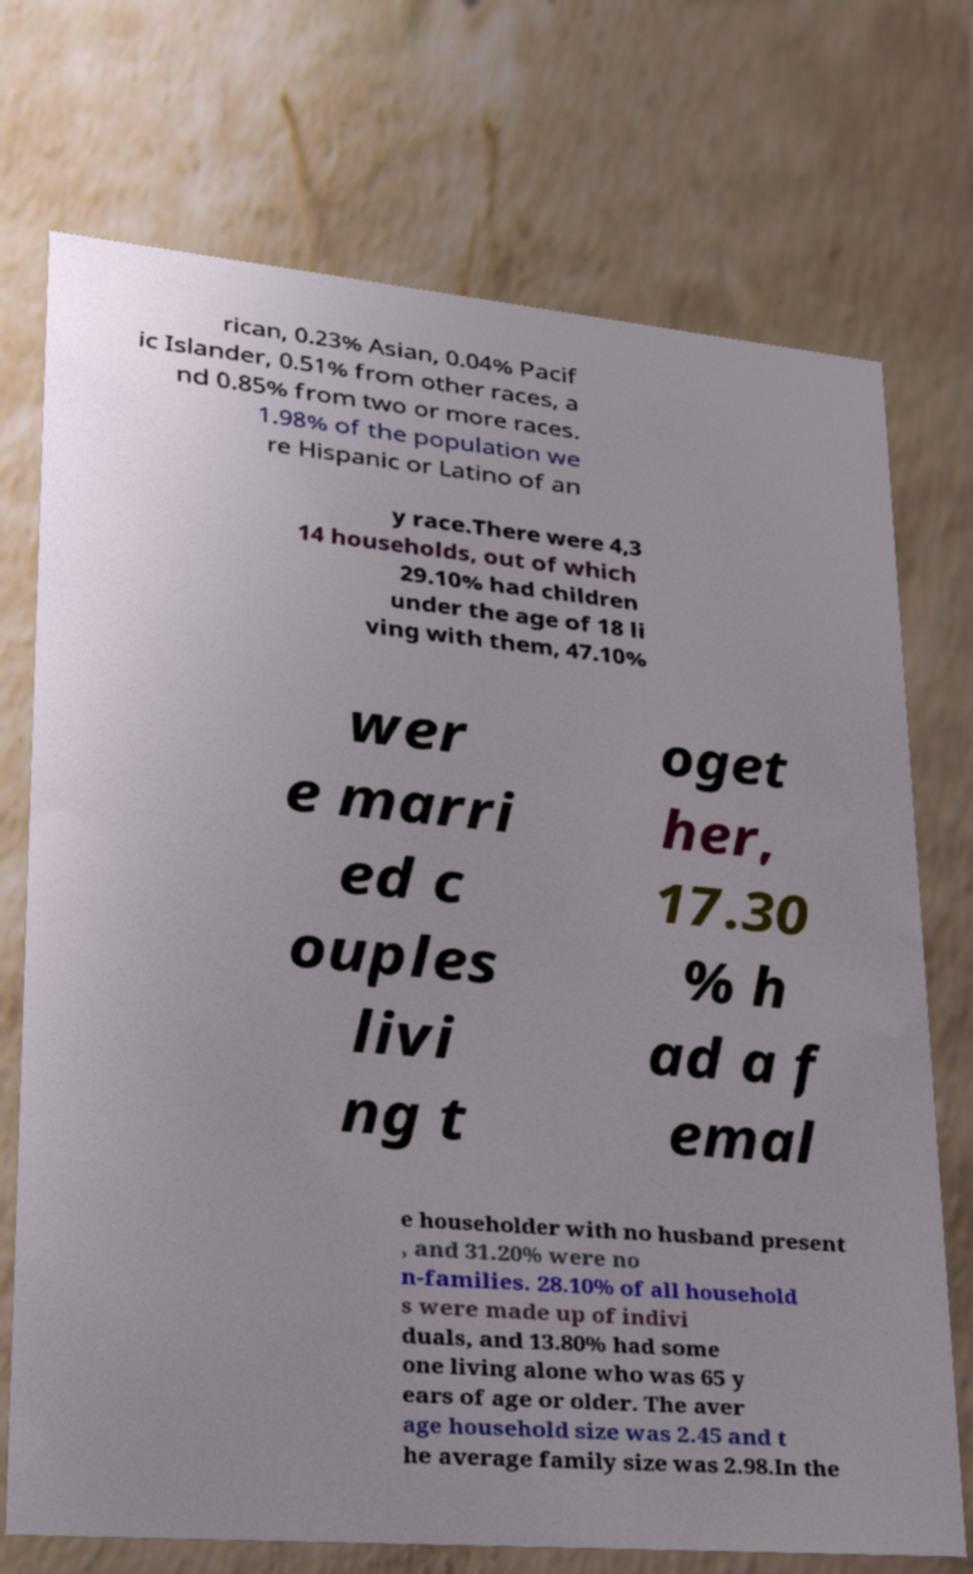Could you extract and type out the text from this image? rican, 0.23% Asian, 0.04% Pacif ic Islander, 0.51% from other races, a nd 0.85% from two or more races. 1.98% of the population we re Hispanic or Latino of an y race.There were 4,3 14 households, out of which 29.10% had children under the age of 18 li ving with them, 47.10% wer e marri ed c ouples livi ng t oget her, 17.30 % h ad a f emal e householder with no husband present , and 31.20% were no n-families. 28.10% of all household s were made up of indivi duals, and 13.80% had some one living alone who was 65 y ears of age or older. The aver age household size was 2.45 and t he average family size was 2.98.In the 